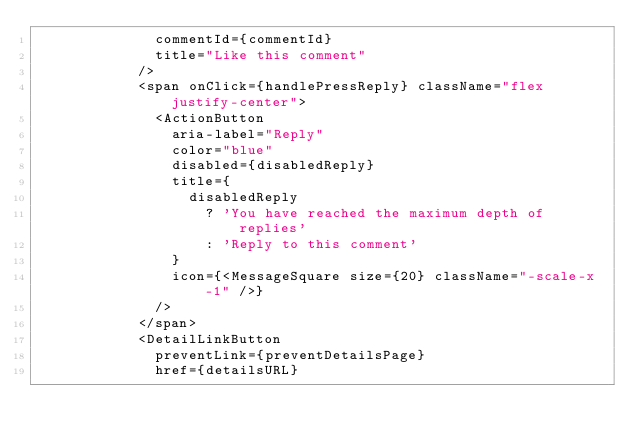Convert code to text. <code><loc_0><loc_0><loc_500><loc_500><_TypeScript_>              commentId={commentId}
              title="Like this comment"
            />
            <span onClick={handlePressReply} className="flex justify-center">
              <ActionButton
                aria-label="Reply"
                color="blue"
                disabled={disabledReply}
                title={
                  disabledReply
                    ? 'You have reached the maximum depth of replies'
                    : 'Reply to this comment'
                }
                icon={<MessageSquare size={20} className="-scale-x-1" />}
              />
            </span>
            <DetailLinkButton
              preventLink={preventDetailsPage}
              href={detailsURL}</code> 